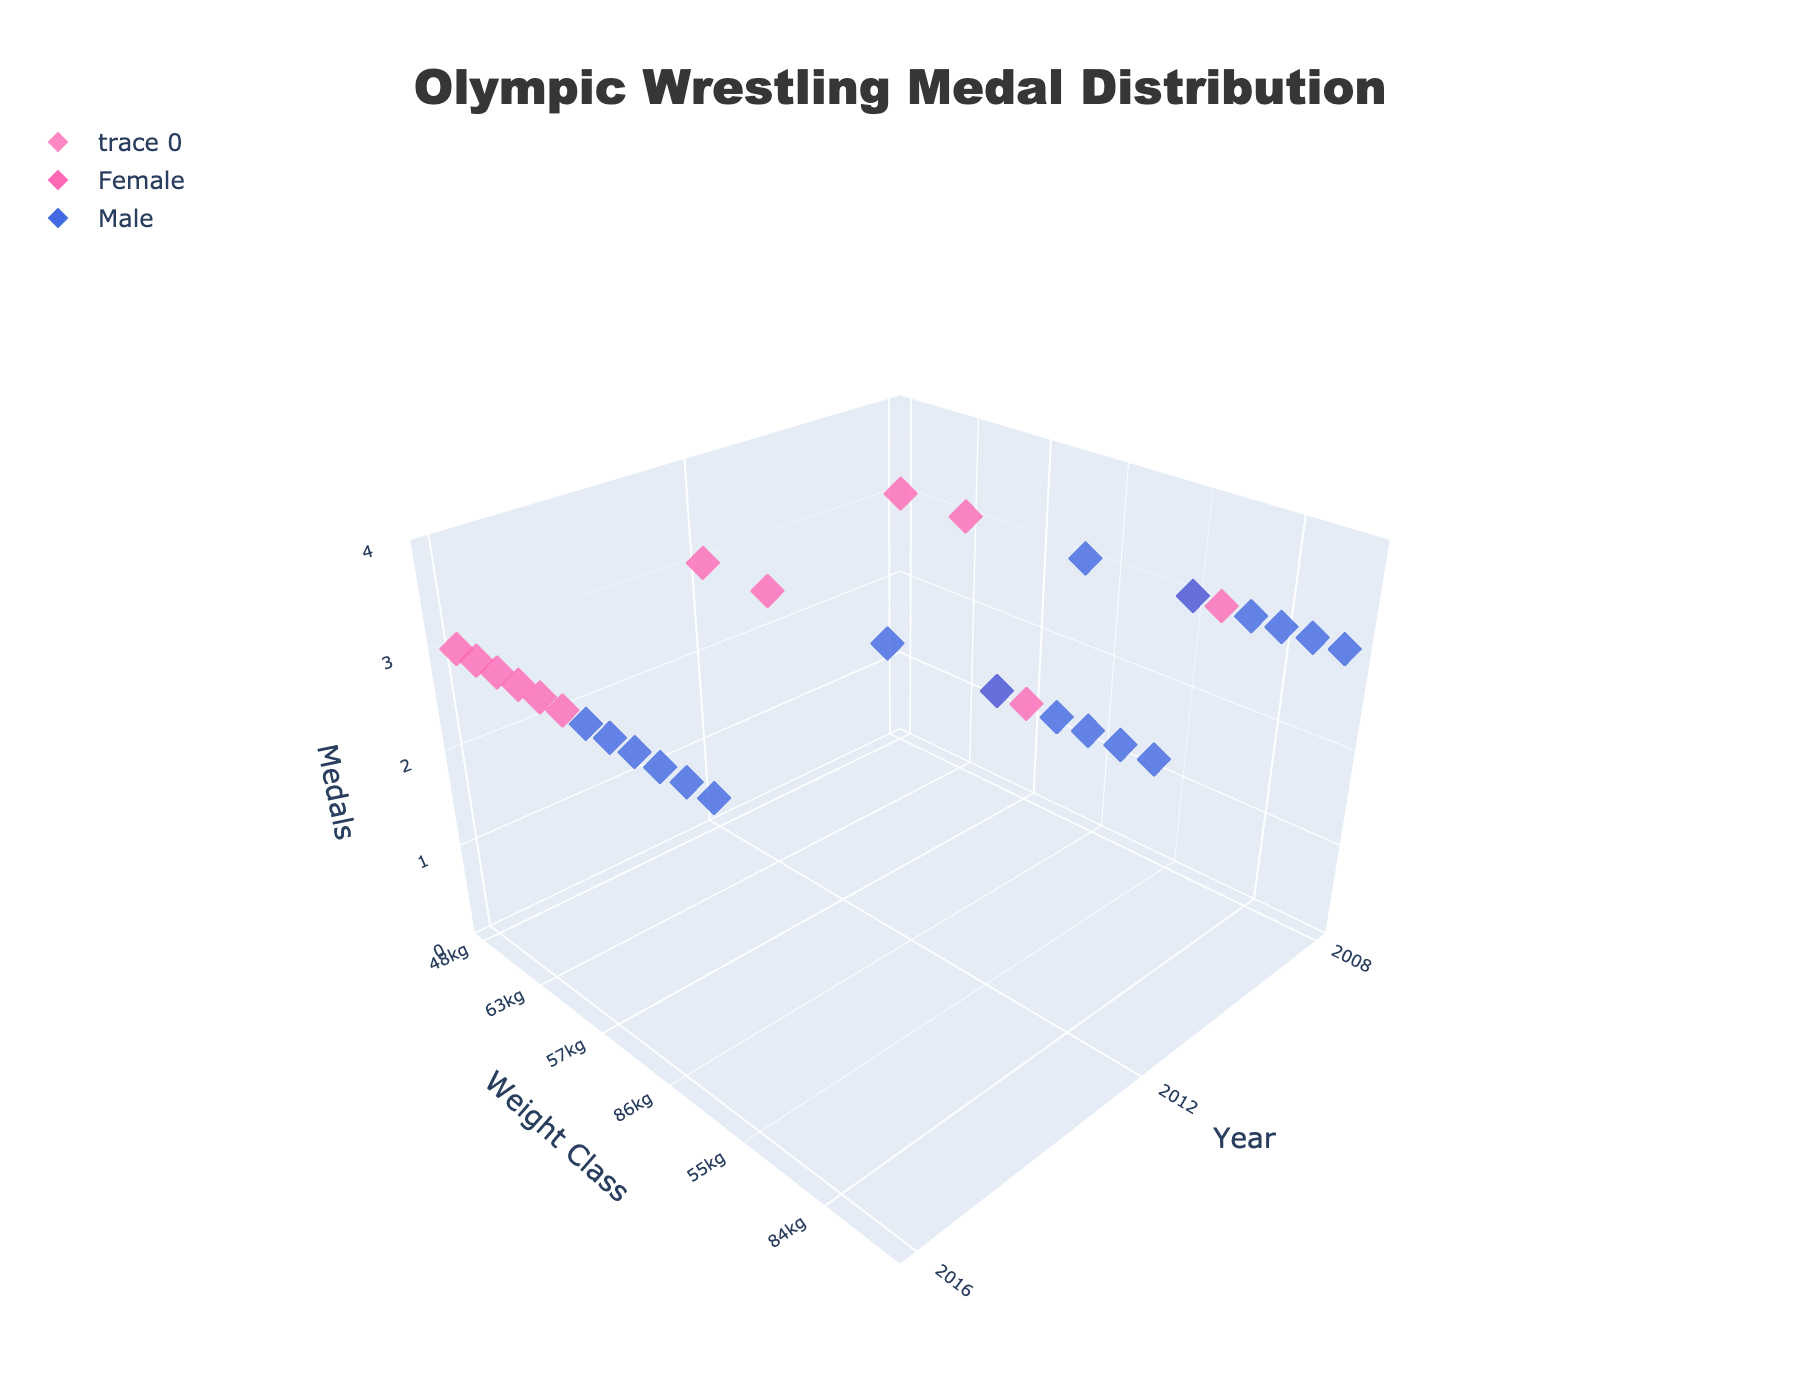What is the title of the figure? To find the title of the figure, look at the top center of the plot.
Answer: Olympic Wrestling Medal Distribution What axis represents the years? To identify the axis for years, look at the axis labels on the plot.
Answer: x-axis How many different weight classes are shown for the year 2016? To determine the number of weight classes in 2016, count the data points along the y-axis where x=2016.
Answer: 12 Which gender is represented by the pink markers? To find which gender corresponds to the pink markers, refer to the custom legend on the plot.
Answer: Female Are there any weight classes where both genders have medals in 2016? Look at the y-axis (weight classes) for the year 2016 and see if both blue and pink markers are found at the same y-values.
Answer: No What is the weight class with the most consistent medals across all years for females? To find the most consistent weight class for females, examine the distribution of pink markers across all years and identify the weight class that appears consistently (e.g., 48kg).
Answer: 48kg Compare the number of female medals in 2008 and 2016. Which year has more? Count the number of pink markers for each year and compare. Both years have the same number.
Answer: Both are equal Which male weight class has the highest number of medals in the provided years? All weight classes for males have the same number of medals across the given years; each weight class has 3 medals.
Answer: All are equal How many total categories (weight classes and genders combined) are represented in the plot? Count the unique combinations of weight classes and genders across all years.
Answer: 27 Which color corresponds to male players, and what symbol is used for the markers? Refer to the custom legend to identify the color and symbol for male players.
Answer: Blue, Diamond 